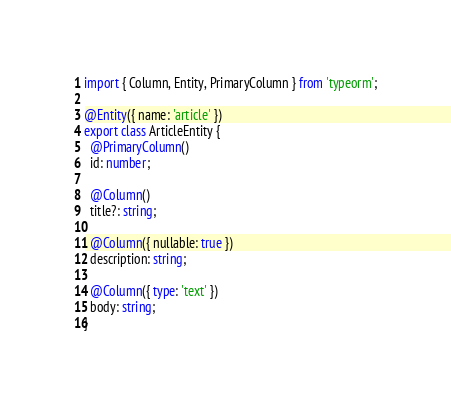<code> <loc_0><loc_0><loc_500><loc_500><_TypeScript_>import { Column, Entity, PrimaryColumn } from 'typeorm';

@Entity({ name: 'article' })
export class ArticleEntity {
  @PrimaryColumn()
  id: number;

  @Column()
  title?: string;

  @Column({ nullable: true })
  description: string;

  @Column({ type: 'text' })
  body: string;
}
</code> 